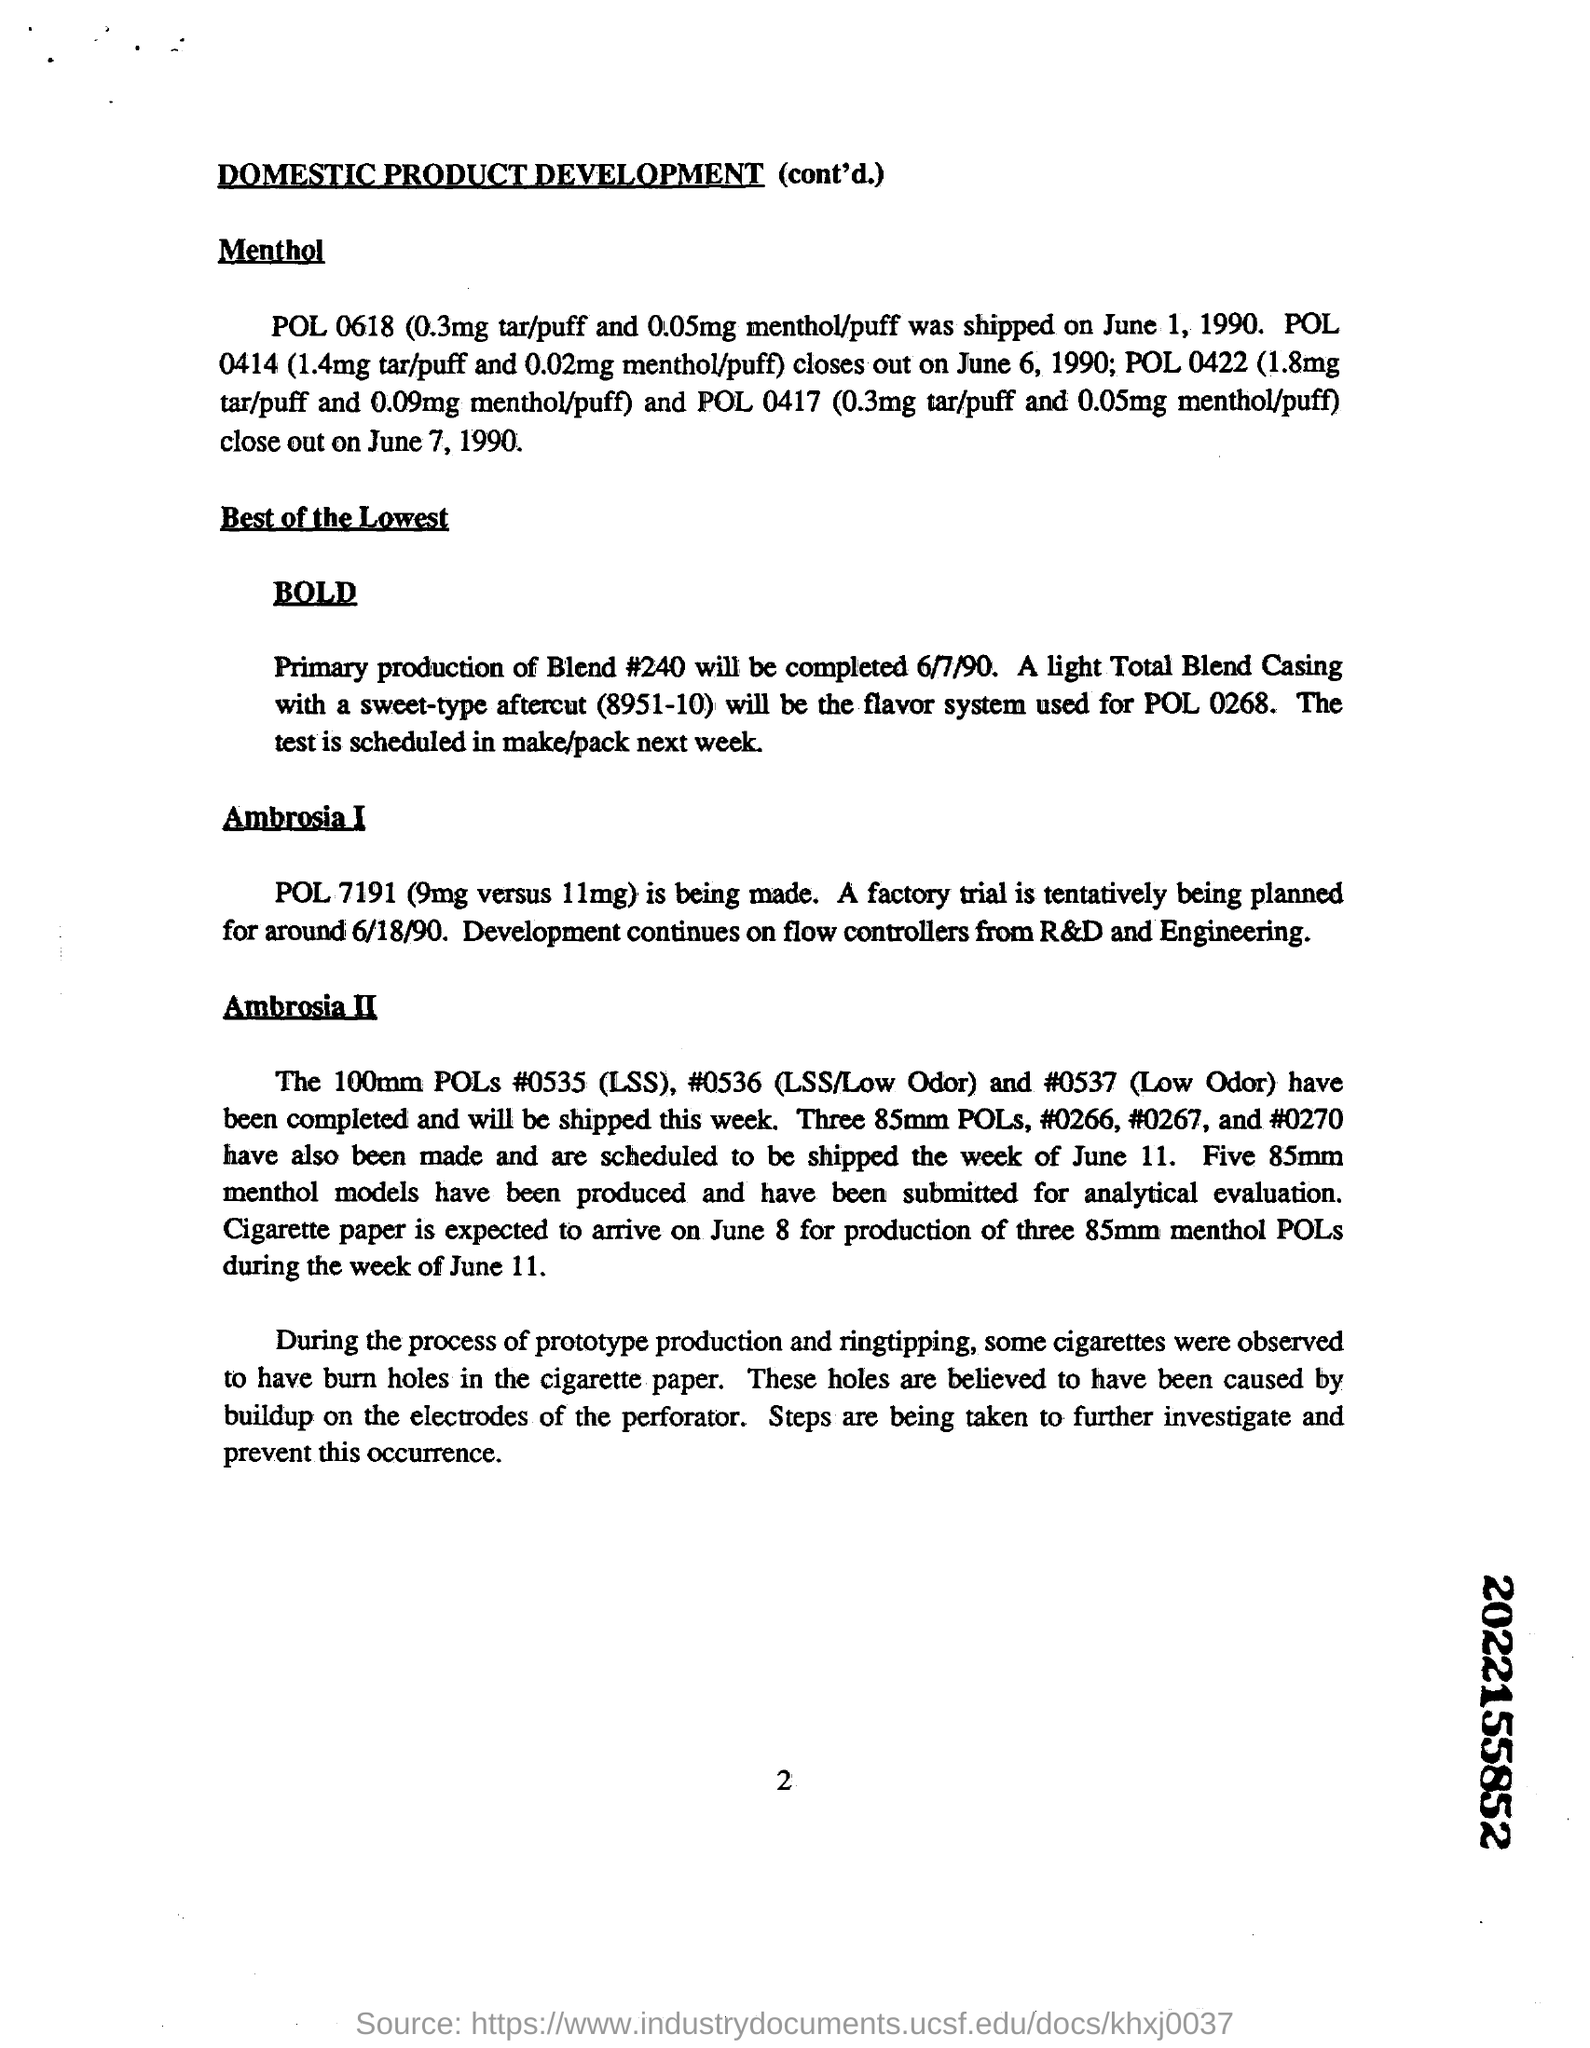Mention a couple of crucial points in this snapshot. Under BOLD, the primary production of Blend #24 is expected to be completed by June 7, 1990. Prototype production and ringtipping resulted in cigarettes with burn holes in the paper, specifically in cigarette paper. 